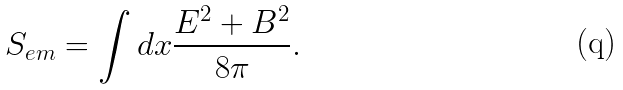<formula> <loc_0><loc_0><loc_500><loc_500>S _ { e m } = \int d x \frac { { E } ^ { 2 } + { B } ^ { 2 } } { 8 \pi } .</formula> 